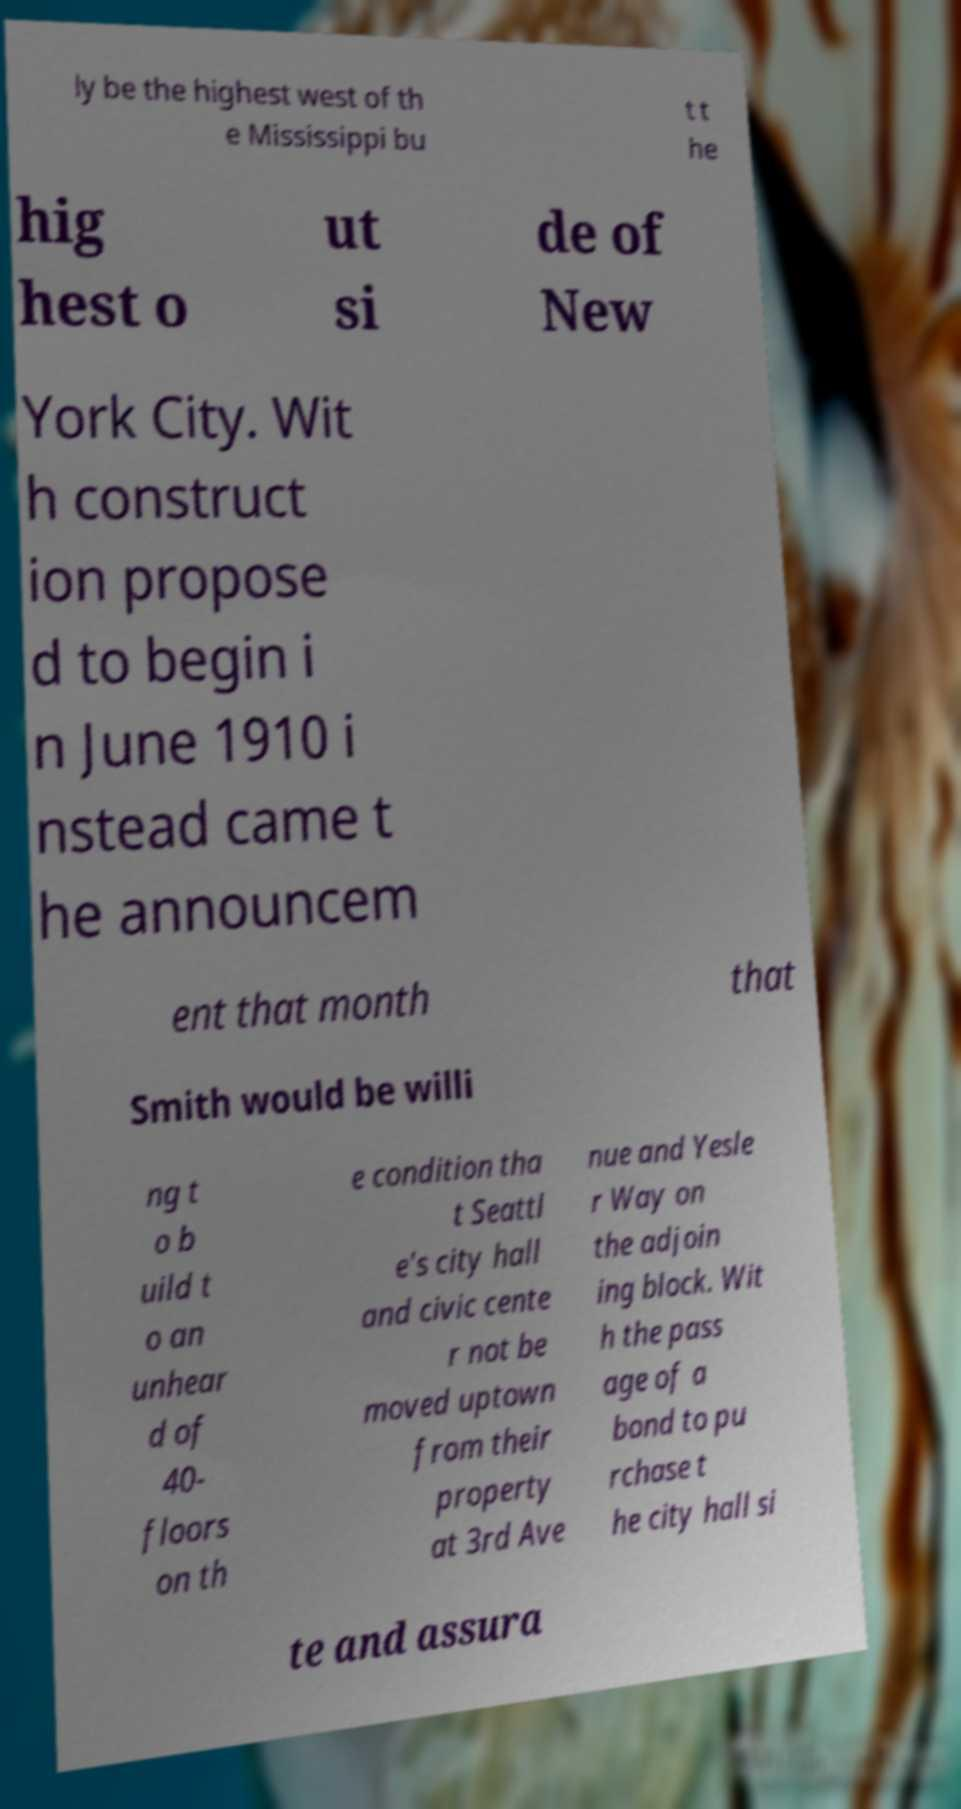What messages or text are displayed in this image? I need them in a readable, typed format. ly be the highest west of th e Mississippi bu t t he hig hest o ut si de of New York City. Wit h construct ion propose d to begin i n June 1910 i nstead came t he announcem ent that month that Smith would be willi ng t o b uild t o an unhear d of 40- floors on th e condition tha t Seattl e's city hall and civic cente r not be moved uptown from their property at 3rd Ave nue and Yesle r Way on the adjoin ing block. Wit h the pass age of a bond to pu rchase t he city hall si te and assura 